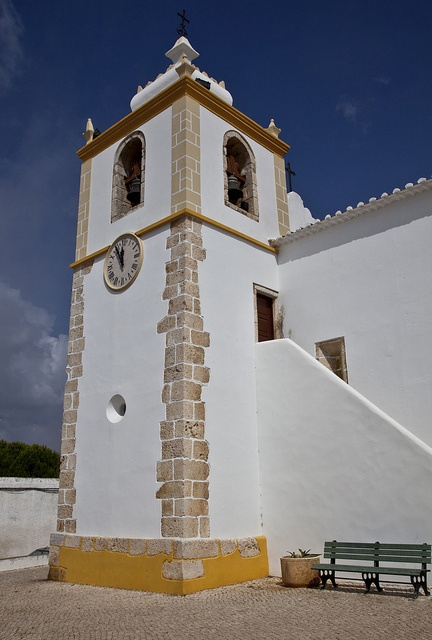Describe the objects in this image and their specific colors. I can see bench in navy, black, darkgray, and gray tones, clock in navy, gray, and black tones, and potted plant in navy, maroon, gray, and black tones in this image. 